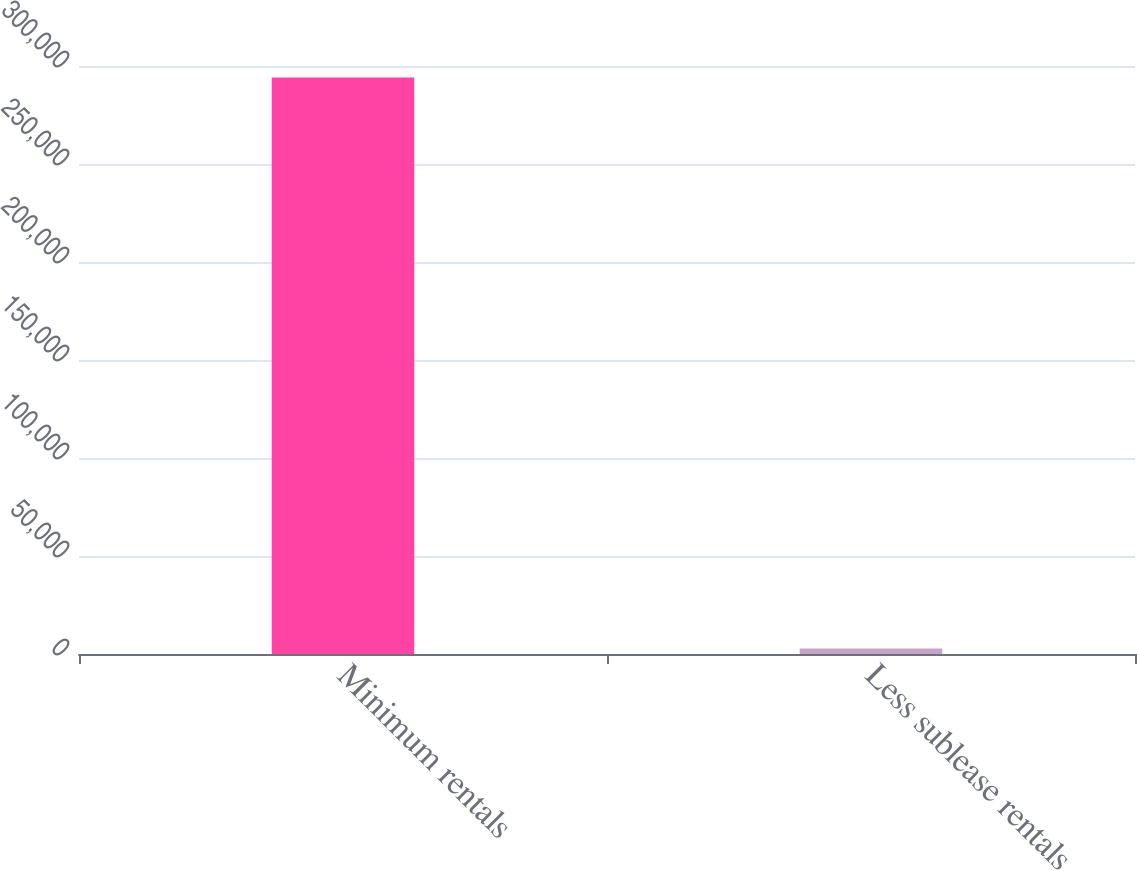Convert chart to OTSL. <chart><loc_0><loc_0><loc_500><loc_500><bar_chart><fcel>Minimum rentals<fcel>Less sublease rentals<nl><fcel>294107<fcel>2808<nl></chart> 